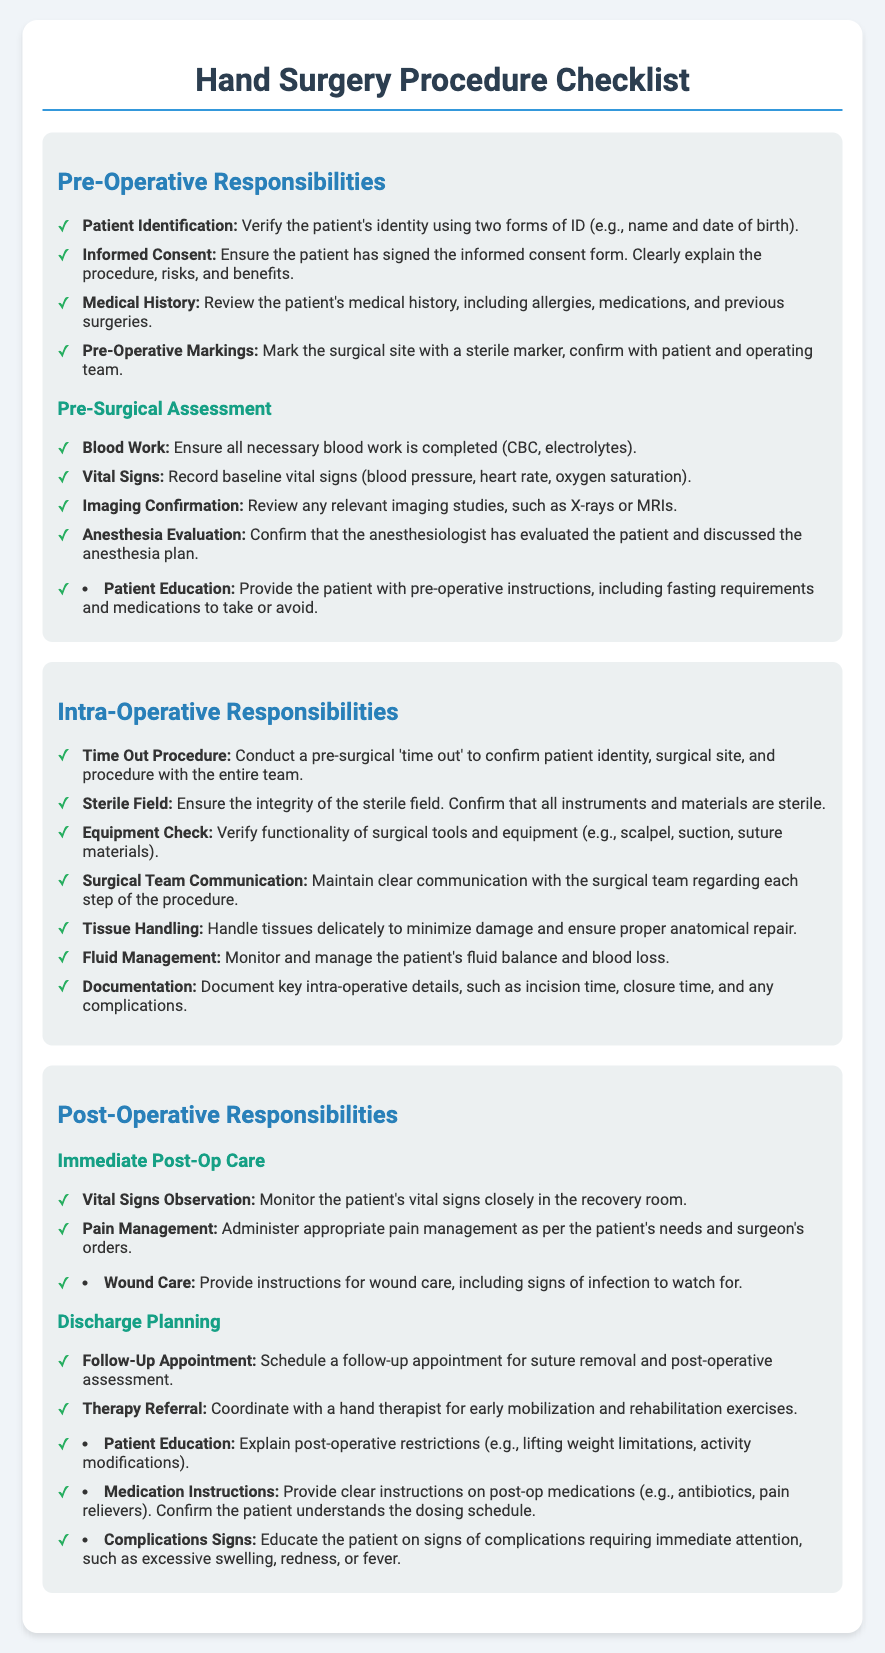What are the pre-operative responsibilities? The pre-operative responsibilities are listed under the 'Pre-Operative Responsibilities' section and consist of verifying patient identification, ensuring informed consent, reviewing medical history, marking the surgical site, conducting blood work, recording vital signs, reviewing imaging studies, and confirming anesthesia evaluation.
Answer: Patient Identification, Informed Consent, Medical History, Pre-Operative Markings, Blood Work, Vital Signs, Imaging Confirmation, Anesthesia Evaluation What should be monitored closely in the recovery room? The document specifies that vital signs should be monitored closely in the recovery room under the post-operative responsibilities.
Answer: Vital Signs What is included in post-operative patient education? The post-operative patient education includes explaining restrictions, providing medication instructions, and educating on signs of complications.
Answer: Restrictions, Medication Instructions, Signs of Complications Name a responsibility during the intra-operative phase. A responsibility during the intra-operative phase includes conducting a pre-surgical 'time out' to confirm patient identity and surgical site.
Answer: Time Out Procedure How many items are listed under immediate post-op care? The immediate post-op care section includes two items related to vital signs observation and pain management.
Answer: 2 What is required for surgical site confirmation before the surgery? Before the surgery, it is required to conduct a 'time out' to confirm patient identity, surgical site, and procedure with the entire team.
Answer: Time Out Procedure What should be provided for wound care? Wound care instructions should include signs of infection to watch for, as mentioned in the post-operative responsibilities.
Answer: Signs of Infection What type of referral should be coordinated post-surgery? The document indicates that a referral should be coordinated with a hand therapist for early mobilization and rehabilitation exercises post-surgery.
Answer: Hand Therapist 